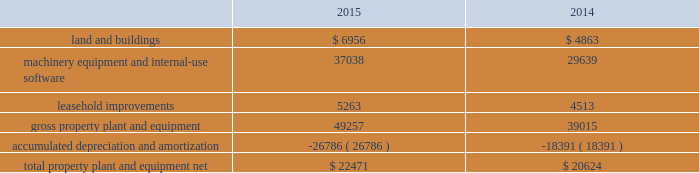Table of contents the notional amounts for outstanding derivative instruments provide one measure of the transaction volume outstanding and do not represent the amount of the company 2019s exposure to credit or market loss .
The credit risk amounts represent the company 2019s gross exposure to potential accounting loss on derivative instruments that are outstanding or unsettled if all counterparties failed to perform according to the terms of the contract , based on then-current currency or interest rates at each respective date .
The company 2019s exposure to credit loss and market risk will vary over time as currency and interest rates change .
Although the table above reflects the notional and credit risk amounts of the company 2019s derivative instruments , it does not reflect the gains or losses associated with the exposures and transactions that the instruments are intended to hedge .
The amounts ultimately realized upon settlement of these financial instruments , together with the gains and losses on the underlying exposures , will depend on actual market conditions during the remaining life of the instruments .
The company generally enters into master netting arrangements , which are designed to reduce credit risk by permitting net settlement of transactions with the same counterparty .
To further limit credit risk , the company generally enters into collateral security arrangements that provide for collateral to be received or posted when the net fair value of certain financial instruments fluctuates from contractually established thresholds .
The company presents its derivative assets and derivative liabilities at their gross fair values in its consolidated balance sheets .
The net cash collateral received by the company related to derivative instruments under its collateral security arrangements was $ 1.0 billion as of september 26 , 2015 and $ 2.1 billion as of september 27 , 2014 .
Under master netting arrangements with the respective counterparties to the company 2019s derivative contracts , the company is allowed to net settle transactions with a single net amount payable by one party to the other .
As of september 26 , 2015 and september 27 , 2014 , the potential effects of these rights of set-off associated with the company 2019s derivative contracts , including the effects of collateral , would be a reduction to both derivative assets and derivative liabilities of $ 2.2 billion and $ 1.6 billion , respectively , resulting in net derivative liabilities of $ 78 million and $ 549 million , respectively .
Accounts receivable receivables the company has considerable trade receivables outstanding with its third-party cellular network carriers , wholesalers , retailers , value-added resellers , small and mid-sized businesses and education , enterprise and government customers .
The company generally does not require collateral from its customers ; however , the company will require collateral in certain instances to limit credit risk .
In addition , when possible , the company attempts to limit credit risk on trade receivables with credit insurance for certain customers or by requiring third-party financing , loans or leases to support credit exposure .
These credit-financing arrangements are directly between the third-party financing company and the end customer .
As such , the company generally does not assume any recourse or credit risk sharing related to any of these arrangements .
As of september 26 , 2015 , the company had one customer that represented 10% ( 10 % ) or more of total trade receivables , which accounted for 12% ( 12 % ) .
As of september 27 , 2014 , the company had two customers that represented 10% ( 10 % ) or more of total trade receivables , one of which accounted for 16% ( 16 % ) and the other 13% ( 13 % ) .
The company 2019s cellular network carriers accounted for 71% ( 71 % ) and 72% ( 72 % ) of trade receivables as of september 26 , 2015 and september 27 , 2014 , respectively .
Vendor non-trade receivables the company has non-trade receivables from certain of its manufacturing vendors resulting from the sale of components to these vendors who manufacture sub-assemblies or assemble final products for the company .
The company purchases these components directly from suppliers .
Vendor non-trade receivables from three of the company 2019s vendors accounted for 38% ( 38 % ) , 18% ( 18 % ) and 14% ( 14 % ) of total vendor non-trade receivables as of september 26 , 2015 and three of the company 2019s vendors accounted for 51% ( 51 % ) , 16% ( 16 % ) and 14% ( 14 % ) of total vendor non-trade receivables as of september 27 , 2014 .
Note 3 2013 consolidated financial statement details the tables show the company 2019s consolidated financial statement details as of september 26 , 2015 and september 27 , 2014 ( in millions ) : property , plant and equipment , net .
Apple inc .
| 2015 form 10-k | 53 .
What was the change in leasehold improvements between 2014 and 2015 , in millions? 
Computations: (5263 - 4513)
Answer: 750.0. 